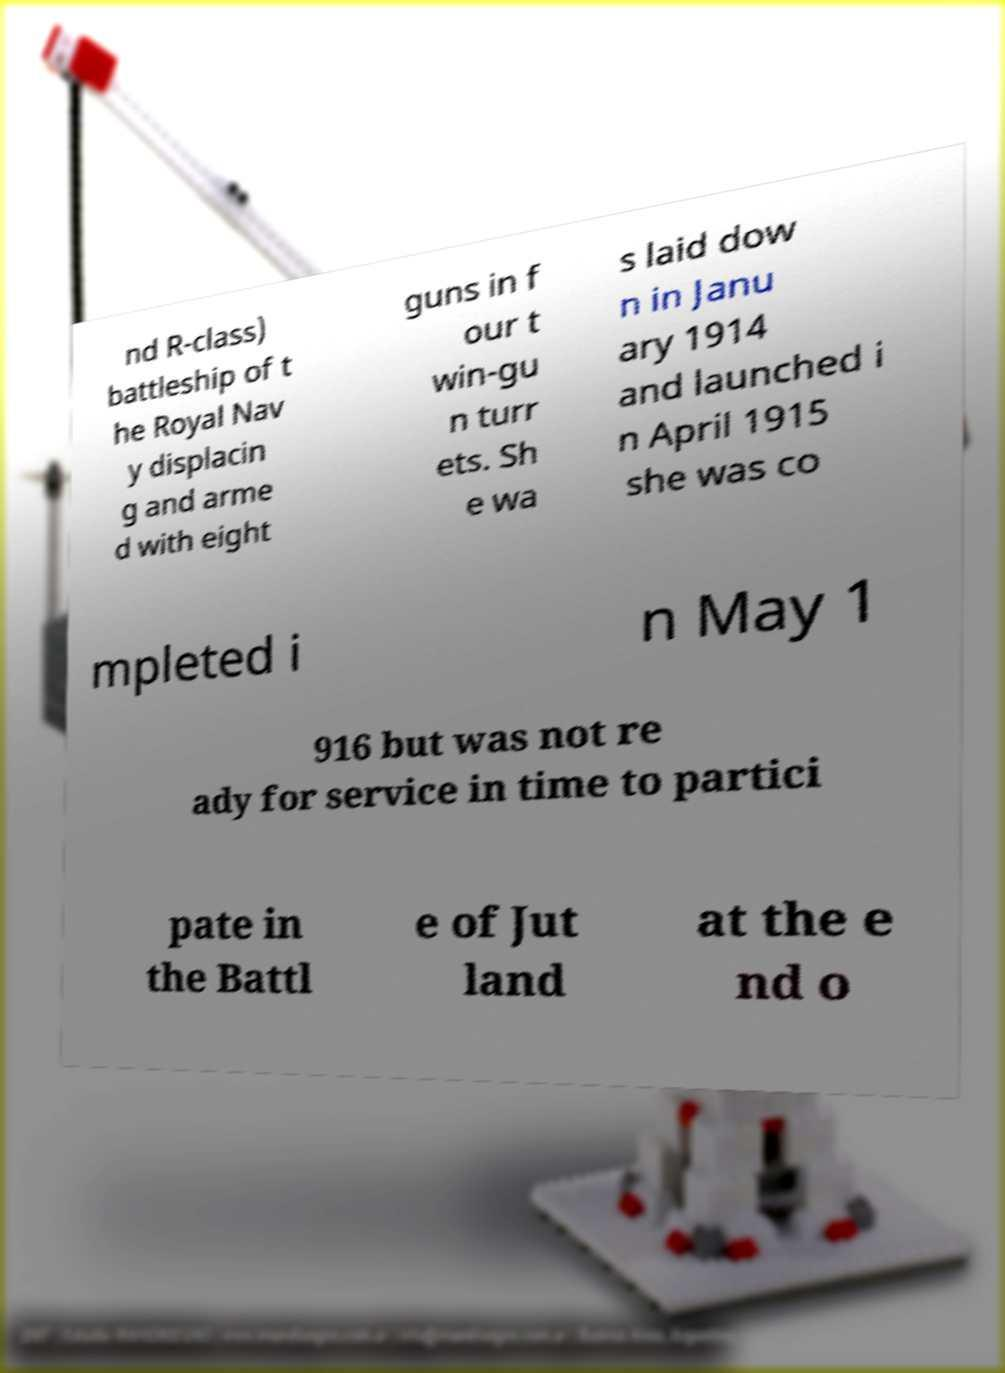I need the written content from this picture converted into text. Can you do that? nd R-class) battleship of t he Royal Nav y displacin g and arme d with eight guns in f our t win-gu n turr ets. Sh e wa s laid dow n in Janu ary 1914 and launched i n April 1915 she was co mpleted i n May 1 916 but was not re ady for service in time to partici pate in the Battl e of Jut land at the e nd o 